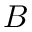Convert formula to latex. <formula><loc_0><loc_0><loc_500><loc_500>B</formula> 